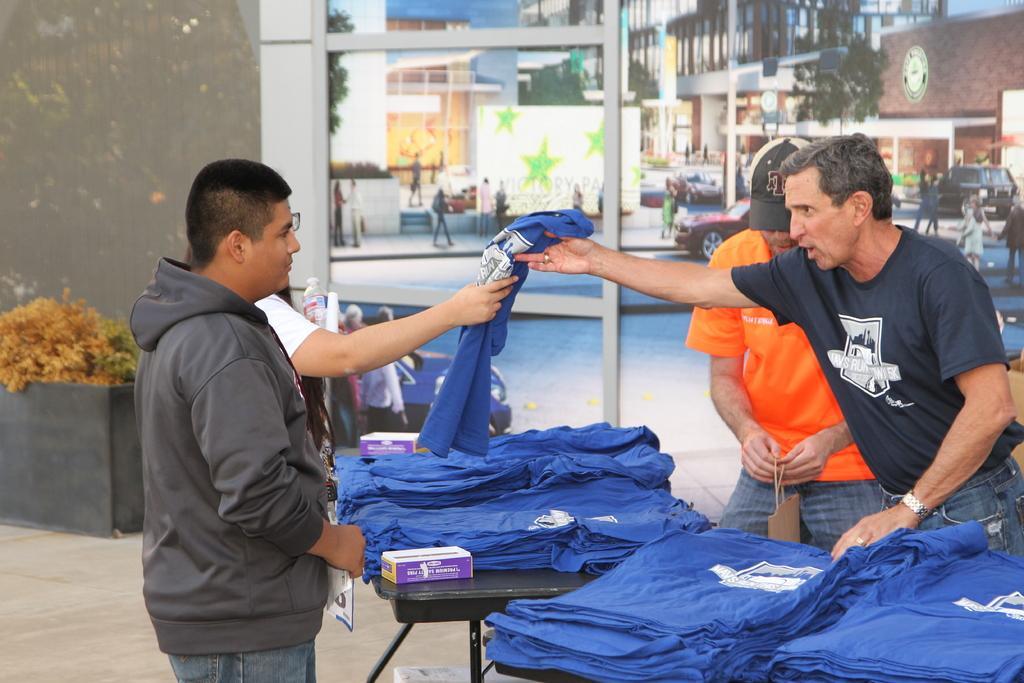In one or two sentences, can you explain what this image depicts? In this image we can see two men are standing and selling blue color garments. In front of them table is there. On table so many blue color garments are kept. Left side of the image two men are standing and purchasing. Background of the image plants, road, cars, trees and buildings are present. 